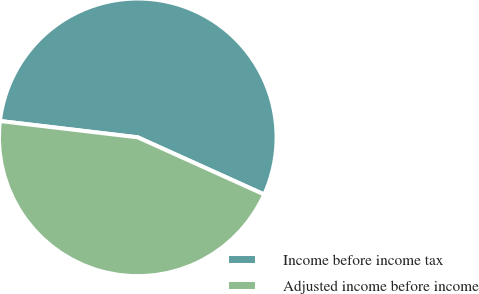Convert chart. <chart><loc_0><loc_0><loc_500><loc_500><pie_chart><fcel>Income before income tax<fcel>Adjusted income before income<nl><fcel>54.88%<fcel>45.12%<nl></chart> 